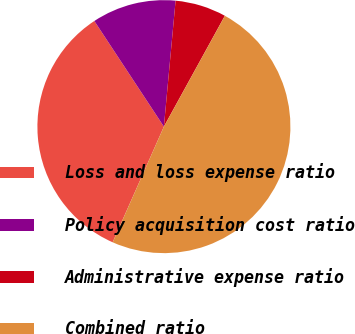Convert chart. <chart><loc_0><loc_0><loc_500><loc_500><pie_chart><fcel>Loss and loss expense ratio<fcel>Policy acquisition cost ratio<fcel>Administrative expense ratio<fcel>Combined ratio<nl><fcel>34.09%<fcel>10.74%<fcel>6.53%<fcel>48.64%<nl></chart> 